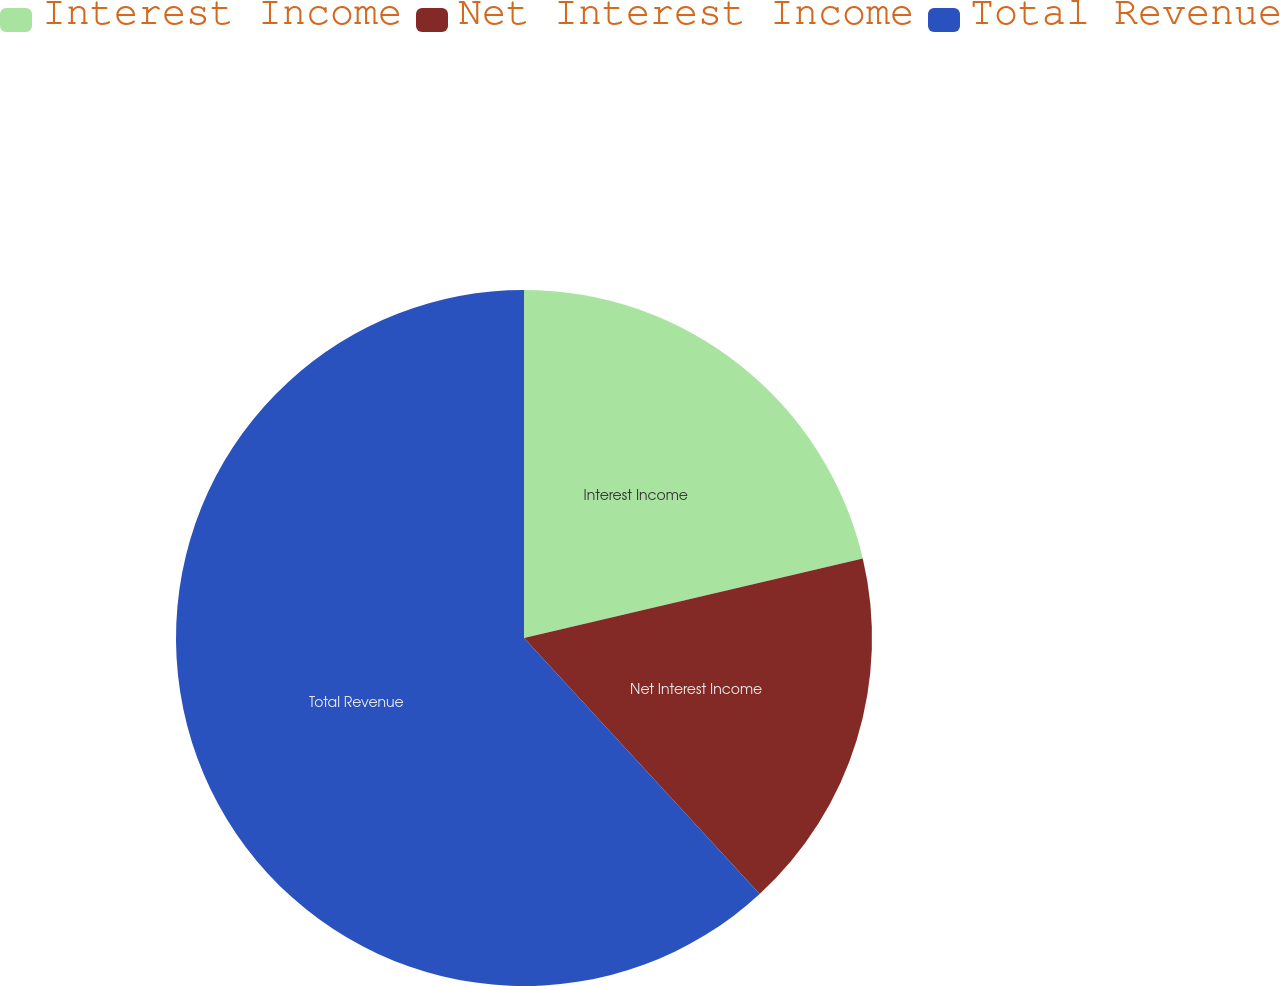Convert chart. <chart><loc_0><loc_0><loc_500><loc_500><pie_chart><fcel>Interest Income<fcel>Net Interest Income<fcel>Total Revenue<nl><fcel>21.33%<fcel>16.83%<fcel>61.84%<nl></chart> 